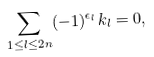<formula> <loc_0><loc_0><loc_500><loc_500>\sum _ { 1 \leq l \leq 2 n } ( - 1 ) ^ { \epsilon _ { l } } k _ { l } = 0 ,</formula> 